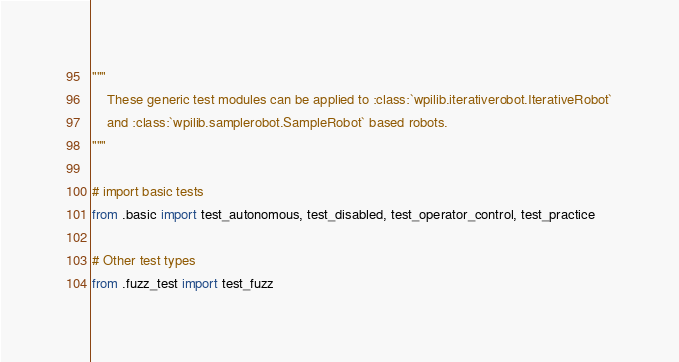Convert code to text. <code><loc_0><loc_0><loc_500><loc_500><_Python_>"""
    These generic test modules can be applied to :class:`wpilib.iterativerobot.IterativeRobot`
    and :class:`wpilib.samplerobot.SampleRobot` based robots.
"""

# import basic tests
from .basic import test_autonomous, test_disabled, test_operator_control, test_practice

# Other test types
from .fuzz_test import test_fuzz
</code> 